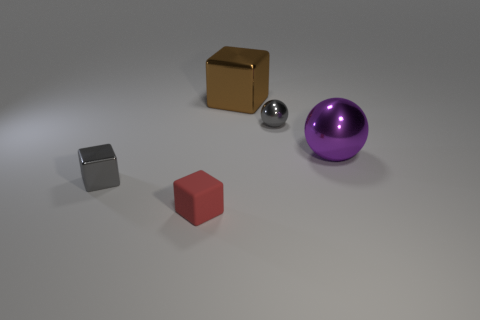There is a thing that is the same color as the small ball; what size is it?
Offer a terse response. Small. Do the gray object behind the purple shiny sphere and the tiny red thing have the same shape?
Keep it short and to the point. No. What material is the small gray block that is on the left side of the small gray sphere?
Your answer should be very brief. Metal. What shape is the tiny shiny thing that is the same color as the small metal ball?
Offer a terse response. Cube. Are there any small purple cylinders made of the same material as the purple thing?
Ensure brevity in your answer.  No. The red matte object has what size?
Give a very brief answer. Small. What number of yellow things are either large shiny spheres or small balls?
Ensure brevity in your answer.  0. What number of other brown metallic objects are the same shape as the brown thing?
Provide a succinct answer. 0. What number of metallic cubes are the same size as the red object?
Your response must be concise. 1. There is a big brown thing that is the same shape as the small red matte thing; what is its material?
Your answer should be very brief. Metal. 